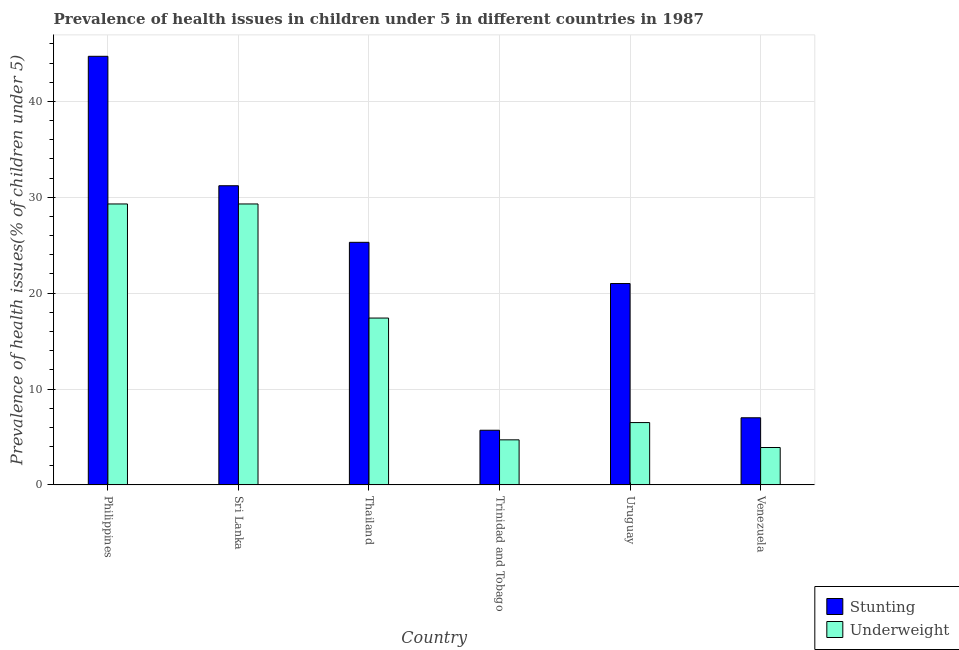How many groups of bars are there?
Provide a succinct answer. 6. Are the number of bars per tick equal to the number of legend labels?
Make the answer very short. Yes. Are the number of bars on each tick of the X-axis equal?
Keep it short and to the point. Yes. How many bars are there on the 3rd tick from the left?
Give a very brief answer. 2. How many bars are there on the 6th tick from the right?
Provide a succinct answer. 2. What is the label of the 1st group of bars from the left?
Ensure brevity in your answer.  Philippines. In how many cases, is the number of bars for a given country not equal to the number of legend labels?
Your response must be concise. 0. What is the percentage of underweight children in Venezuela?
Your response must be concise. 3.9. Across all countries, what is the maximum percentage of stunted children?
Your answer should be very brief. 44.7. Across all countries, what is the minimum percentage of stunted children?
Make the answer very short. 5.7. In which country was the percentage of underweight children minimum?
Offer a terse response. Venezuela. What is the total percentage of underweight children in the graph?
Provide a short and direct response. 91.1. What is the difference between the percentage of stunted children in Sri Lanka and that in Uruguay?
Provide a short and direct response. 10.2. What is the difference between the percentage of underweight children in Sri Lanka and the percentage of stunted children in Venezuela?
Keep it short and to the point. 22.3. What is the average percentage of underweight children per country?
Offer a very short reply. 15.18. What is the difference between the percentage of stunted children and percentage of underweight children in Uruguay?
Provide a short and direct response. 14.5. In how many countries, is the percentage of stunted children greater than 24 %?
Provide a succinct answer. 3. What is the ratio of the percentage of stunted children in Sri Lanka to that in Uruguay?
Offer a very short reply. 1.49. Is the percentage of underweight children in Sri Lanka less than that in Uruguay?
Provide a short and direct response. No. What is the difference between the highest and the second highest percentage of stunted children?
Provide a succinct answer. 13.5. What is the difference between the highest and the lowest percentage of stunted children?
Your answer should be very brief. 39. In how many countries, is the percentage of underweight children greater than the average percentage of underweight children taken over all countries?
Keep it short and to the point. 3. What does the 2nd bar from the left in Philippines represents?
Ensure brevity in your answer.  Underweight. What does the 1st bar from the right in Trinidad and Tobago represents?
Keep it short and to the point. Underweight. How many countries are there in the graph?
Offer a very short reply. 6. What is the difference between two consecutive major ticks on the Y-axis?
Provide a succinct answer. 10. Does the graph contain any zero values?
Offer a very short reply. No. Where does the legend appear in the graph?
Ensure brevity in your answer.  Bottom right. What is the title of the graph?
Your answer should be very brief. Prevalence of health issues in children under 5 in different countries in 1987. Does "Highest 10% of population" appear as one of the legend labels in the graph?
Offer a terse response. No. What is the label or title of the Y-axis?
Provide a succinct answer. Prevalence of health issues(% of children under 5). What is the Prevalence of health issues(% of children under 5) of Stunting in Philippines?
Your answer should be compact. 44.7. What is the Prevalence of health issues(% of children under 5) of Underweight in Philippines?
Keep it short and to the point. 29.3. What is the Prevalence of health issues(% of children under 5) in Stunting in Sri Lanka?
Offer a very short reply. 31.2. What is the Prevalence of health issues(% of children under 5) in Underweight in Sri Lanka?
Provide a short and direct response. 29.3. What is the Prevalence of health issues(% of children under 5) in Stunting in Thailand?
Keep it short and to the point. 25.3. What is the Prevalence of health issues(% of children under 5) of Underweight in Thailand?
Ensure brevity in your answer.  17.4. What is the Prevalence of health issues(% of children under 5) in Stunting in Trinidad and Tobago?
Offer a very short reply. 5.7. What is the Prevalence of health issues(% of children under 5) of Underweight in Trinidad and Tobago?
Your response must be concise. 4.7. What is the Prevalence of health issues(% of children under 5) of Underweight in Venezuela?
Offer a terse response. 3.9. Across all countries, what is the maximum Prevalence of health issues(% of children under 5) of Stunting?
Ensure brevity in your answer.  44.7. Across all countries, what is the maximum Prevalence of health issues(% of children under 5) of Underweight?
Offer a terse response. 29.3. Across all countries, what is the minimum Prevalence of health issues(% of children under 5) in Stunting?
Ensure brevity in your answer.  5.7. Across all countries, what is the minimum Prevalence of health issues(% of children under 5) in Underweight?
Offer a terse response. 3.9. What is the total Prevalence of health issues(% of children under 5) of Stunting in the graph?
Your answer should be very brief. 134.9. What is the total Prevalence of health issues(% of children under 5) in Underweight in the graph?
Your answer should be very brief. 91.1. What is the difference between the Prevalence of health issues(% of children under 5) in Stunting in Philippines and that in Sri Lanka?
Your response must be concise. 13.5. What is the difference between the Prevalence of health issues(% of children under 5) in Stunting in Philippines and that in Trinidad and Tobago?
Your response must be concise. 39. What is the difference between the Prevalence of health issues(% of children under 5) in Underweight in Philippines and that in Trinidad and Tobago?
Your answer should be very brief. 24.6. What is the difference between the Prevalence of health issues(% of children under 5) of Stunting in Philippines and that in Uruguay?
Offer a very short reply. 23.7. What is the difference between the Prevalence of health issues(% of children under 5) of Underweight in Philippines and that in Uruguay?
Your answer should be very brief. 22.8. What is the difference between the Prevalence of health issues(% of children under 5) in Stunting in Philippines and that in Venezuela?
Offer a terse response. 37.7. What is the difference between the Prevalence of health issues(% of children under 5) of Underweight in Philippines and that in Venezuela?
Provide a short and direct response. 25.4. What is the difference between the Prevalence of health issues(% of children under 5) in Stunting in Sri Lanka and that in Thailand?
Provide a succinct answer. 5.9. What is the difference between the Prevalence of health issues(% of children under 5) of Underweight in Sri Lanka and that in Trinidad and Tobago?
Your answer should be very brief. 24.6. What is the difference between the Prevalence of health issues(% of children under 5) of Stunting in Sri Lanka and that in Uruguay?
Ensure brevity in your answer.  10.2. What is the difference between the Prevalence of health issues(% of children under 5) of Underweight in Sri Lanka and that in Uruguay?
Provide a short and direct response. 22.8. What is the difference between the Prevalence of health issues(% of children under 5) in Stunting in Sri Lanka and that in Venezuela?
Provide a succinct answer. 24.2. What is the difference between the Prevalence of health issues(% of children under 5) in Underweight in Sri Lanka and that in Venezuela?
Offer a terse response. 25.4. What is the difference between the Prevalence of health issues(% of children under 5) of Stunting in Thailand and that in Trinidad and Tobago?
Provide a succinct answer. 19.6. What is the difference between the Prevalence of health issues(% of children under 5) in Underweight in Thailand and that in Trinidad and Tobago?
Your answer should be very brief. 12.7. What is the difference between the Prevalence of health issues(% of children under 5) in Stunting in Thailand and that in Uruguay?
Offer a very short reply. 4.3. What is the difference between the Prevalence of health issues(% of children under 5) of Stunting in Trinidad and Tobago and that in Uruguay?
Your answer should be very brief. -15.3. What is the difference between the Prevalence of health issues(% of children under 5) of Underweight in Trinidad and Tobago and that in Uruguay?
Your response must be concise. -1.8. What is the difference between the Prevalence of health issues(% of children under 5) in Stunting in Trinidad and Tobago and that in Venezuela?
Keep it short and to the point. -1.3. What is the difference between the Prevalence of health issues(% of children under 5) of Underweight in Uruguay and that in Venezuela?
Make the answer very short. 2.6. What is the difference between the Prevalence of health issues(% of children under 5) in Stunting in Philippines and the Prevalence of health issues(% of children under 5) in Underweight in Thailand?
Ensure brevity in your answer.  27.3. What is the difference between the Prevalence of health issues(% of children under 5) in Stunting in Philippines and the Prevalence of health issues(% of children under 5) in Underweight in Uruguay?
Offer a very short reply. 38.2. What is the difference between the Prevalence of health issues(% of children under 5) of Stunting in Philippines and the Prevalence of health issues(% of children under 5) of Underweight in Venezuela?
Your response must be concise. 40.8. What is the difference between the Prevalence of health issues(% of children under 5) in Stunting in Sri Lanka and the Prevalence of health issues(% of children under 5) in Underweight in Uruguay?
Your answer should be compact. 24.7. What is the difference between the Prevalence of health issues(% of children under 5) in Stunting in Sri Lanka and the Prevalence of health issues(% of children under 5) in Underweight in Venezuela?
Your answer should be very brief. 27.3. What is the difference between the Prevalence of health issues(% of children under 5) in Stunting in Thailand and the Prevalence of health issues(% of children under 5) in Underweight in Trinidad and Tobago?
Make the answer very short. 20.6. What is the difference between the Prevalence of health issues(% of children under 5) in Stunting in Thailand and the Prevalence of health issues(% of children under 5) in Underweight in Venezuela?
Provide a succinct answer. 21.4. What is the difference between the Prevalence of health issues(% of children under 5) of Stunting in Trinidad and Tobago and the Prevalence of health issues(% of children under 5) of Underweight in Uruguay?
Offer a very short reply. -0.8. What is the average Prevalence of health issues(% of children under 5) of Stunting per country?
Keep it short and to the point. 22.48. What is the average Prevalence of health issues(% of children under 5) of Underweight per country?
Provide a short and direct response. 15.18. What is the difference between the Prevalence of health issues(% of children under 5) of Stunting and Prevalence of health issues(% of children under 5) of Underweight in Thailand?
Ensure brevity in your answer.  7.9. What is the difference between the Prevalence of health issues(% of children under 5) in Stunting and Prevalence of health issues(% of children under 5) in Underweight in Uruguay?
Give a very brief answer. 14.5. What is the ratio of the Prevalence of health issues(% of children under 5) of Stunting in Philippines to that in Sri Lanka?
Your response must be concise. 1.43. What is the ratio of the Prevalence of health issues(% of children under 5) of Stunting in Philippines to that in Thailand?
Your answer should be compact. 1.77. What is the ratio of the Prevalence of health issues(% of children under 5) of Underweight in Philippines to that in Thailand?
Provide a short and direct response. 1.68. What is the ratio of the Prevalence of health issues(% of children under 5) in Stunting in Philippines to that in Trinidad and Tobago?
Offer a very short reply. 7.84. What is the ratio of the Prevalence of health issues(% of children under 5) in Underweight in Philippines to that in Trinidad and Tobago?
Offer a terse response. 6.23. What is the ratio of the Prevalence of health issues(% of children under 5) in Stunting in Philippines to that in Uruguay?
Make the answer very short. 2.13. What is the ratio of the Prevalence of health issues(% of children under 5) in Underweight in Philippines to that in Uruguay?
Your response must be concise. 4.51. What is the ratio of the Prevalence of health issues(% of children under 5) in Stunting in Philippines to that in Venezuela?
Your answer should be compact. 6.39. What is the ratio of the Prevalence of health issues(% of children under 5) in Underweight in Philippines to that in Venezuela?
Your answer should be compact. 7.51. What is the ratio of the Prevalence of health issues(% of children under 5) of Stunting in Sri Lanka to that in Thailand?
Offer a terse response. 1.23. What is the ratio of the Prevalence of health issues(% of children under 5) in Underweight in Sri Lanka to that in Thailand?
Ensure brevity in your answer.  1.68. What is the ratio of the Prevalence of health issues(% of children under 5) of Stunting in Sri Lanka to that in Trinidad and Tobago?
Offer a very short reply. 5.47. What is the ratio of the Prevalence of health issues(% of children under 5) of Underweight in Sri Lanka to that in Trinidad and Tobago?
Offer a very short reply. 6.23. What is the ratio of the Prevalence of health issues(% of children under 5) of Stunting in Sri Lanka to that in Uruguay?
Make the answer very short. 1.49. What is the ratio of the Prevalence of health issues(% of children under 5) of Underweight in Sri Lanka to that in Uruguay?
Offer a terse response. 4.51. What is the ratio of the Prevalence of health issues(% of children under 5) in Stunting in Sri Lanka to that in Venezuela?
Ensure brevity in your answer.  4.46. What is the ratio of the Prevalence of health issues(% of children under 5) in Underweight in Sri Lanka to that in Venezuela?
Ensure brevity in your answer.  7.51. What is the ratio of the Prevalence of health issues(% of children under 5) of Stunting in Thailand to that in Trinidad and Tobago?
Your response must be concise. 4.44. What is the ratio of the Prevalence of health issues(% of children under 5) of Underweight in Thailand to that in Trinidad and Tobago?
Your answer should be very brief. 3.7. What is the ratio of the Prevalence of health issues(% of children under 5) of Stunting in Thailand to that in Uruguay?
Your response must be concise. 1.2. What is the ratio of the Prevalence of health issues(% of children under 5) in Underweight in Thailand to that in Uruguay?
Offer a very short reply. 2.68. What is the ratio of the Prevalence of health issues(% of children under 5) of Stunting in Thailand to that in Venezuela?
Offer a terse response. 3.61. What is the ratio of the Prevalence of health issues(% of children under 5) of Underweight in Thailand to that in Venezuela?
Offer a very short reply. 4.46. What is the ratio of the Prevalence of health issues(% of children under 5) in Stunting in Trinidad and Tobago to that in Uruguay?
Your response must be concise. 0.27. What is the ratio of the Prevalence of health issues(% of children under 5) of Underweight in Trinidad and Tobago to that in Uruguay?
Offer a very short reply. 0.72. What is the ratio of the Prevalence of health issues(% of children under 5) of Stunting in Trinidad and Tobago to that in Venezuela?
Ensure brevity in your answer.  0.81. What is the ratio of the Prevalence of health issues(% of children under 5) of Underweight in Trinidad and Tobago to that in Venezuela?
Keep it short and to the point. 1.21. What is the ratio of the Prevalence of health issues(% of children under 5) in Underweight in Uruguay to that in Venezuela?
Keep it short and to the point. 1.67. What is the difference between the highest and the second highest Prevalence of health issues(% of children under 5) of Underweight?
Provide a succinct answer. 0. What is the difference between the highest and the lowest Prevalence of health issues(% of children under 5) of Underweight?
Ensure brevity in your answer.  25.4. 